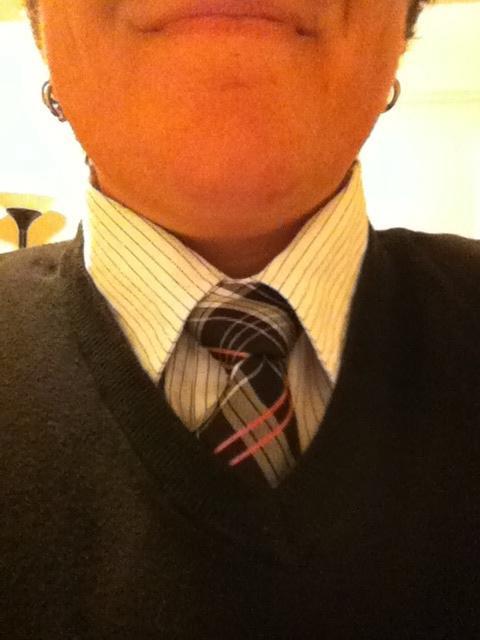Is the shirt checkered?
Concise answer only. No. What type of tie is this?
Be succinct. Plaid. Is this person wearing a tie?
Short answer required. Yes. Is the man wearing a sweater?
Answer briefly. Yes. 